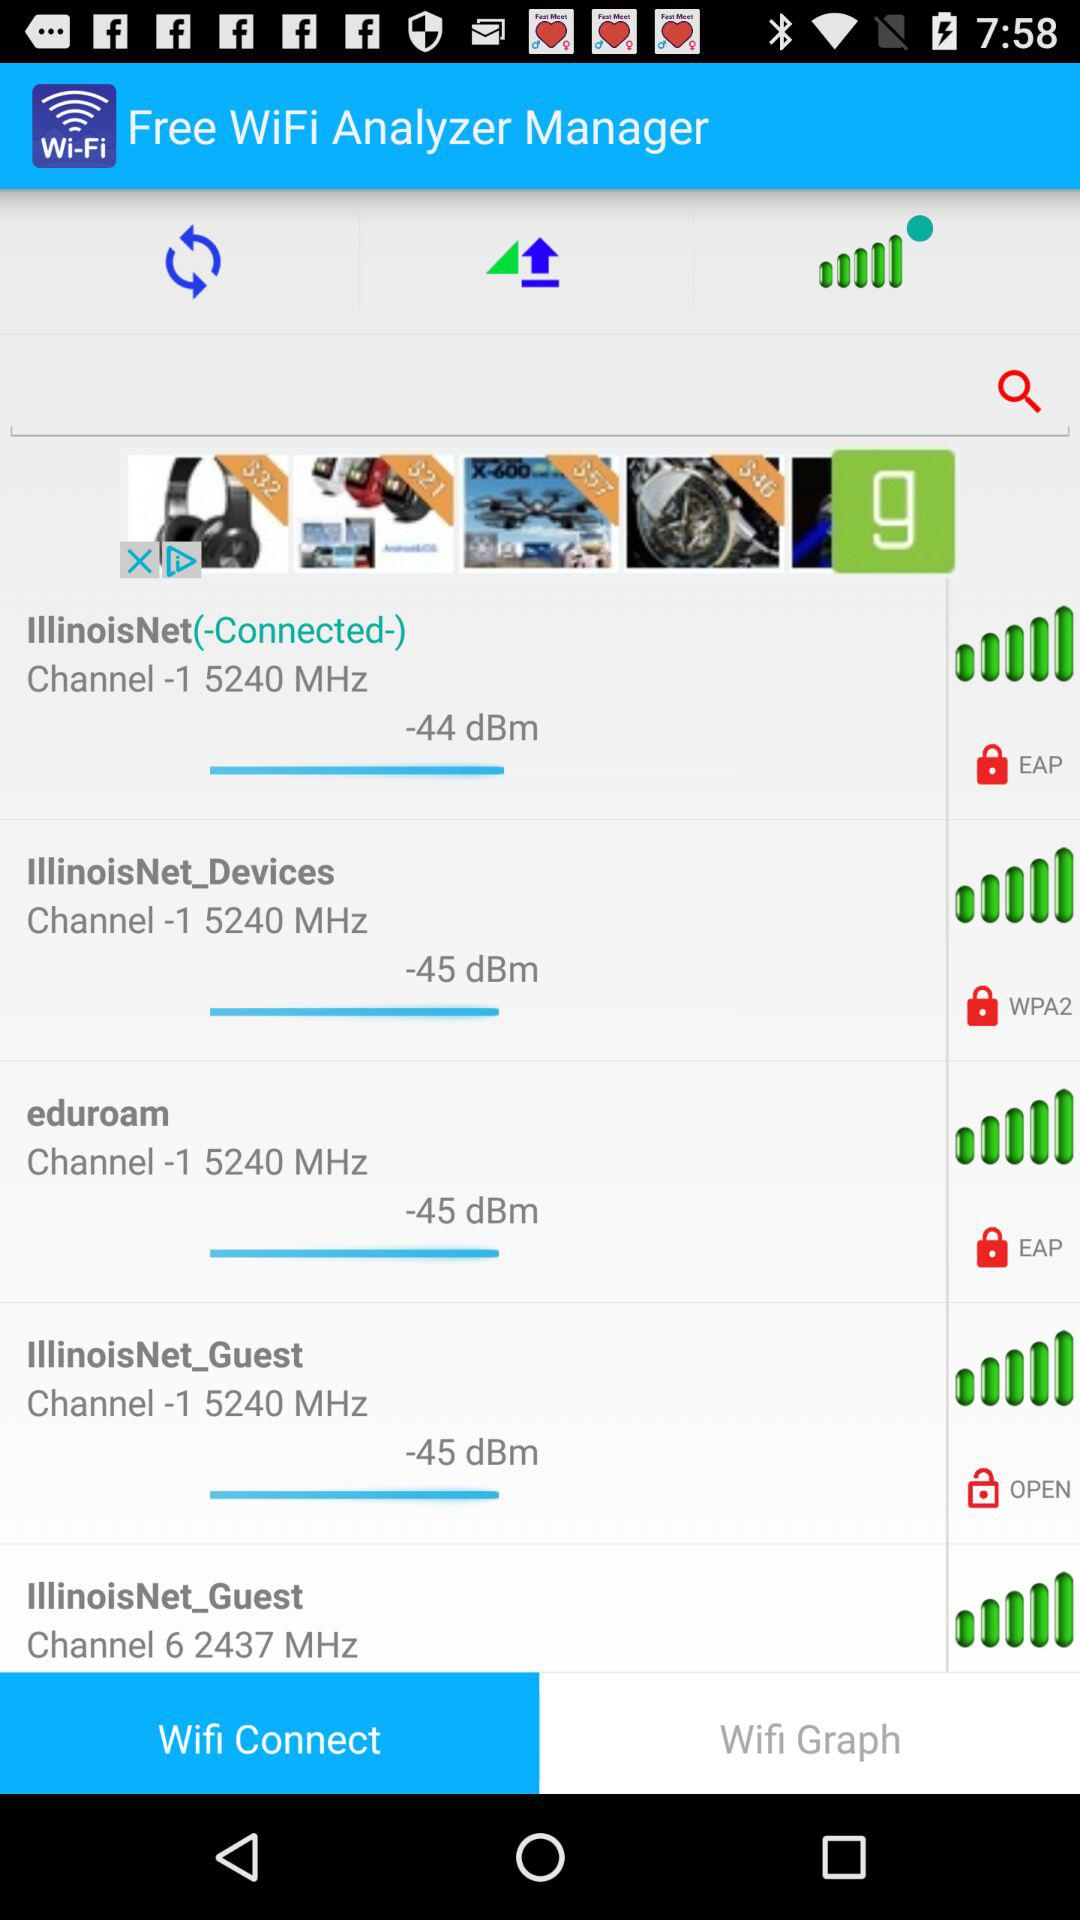Which of these is the open wifi? The open wifi is "IllinoisNet_Guest". 